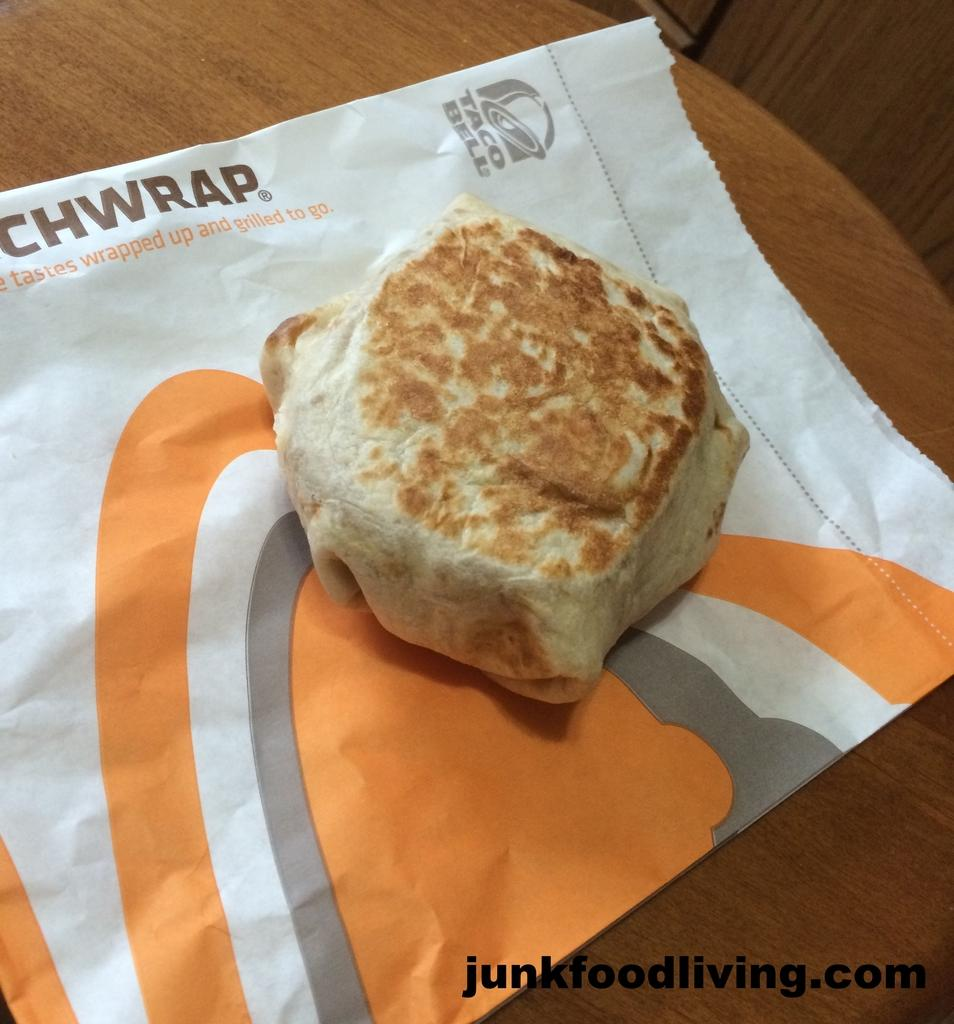What type of surface is visible in the image? There is a wooden surface in the image. What is placed on top of the wooden surface? There is a paper cover on the wooden surface. What can be found on the paper cover? There is a food item on the paper cover. Where is the logo located in the image? The junk food living.com logo is in the right bottom corner of the image. What type of music can be heard playing in the background of the image? There is no music playing in the background of the image, as it is a still image and does not contain any audible elements. 